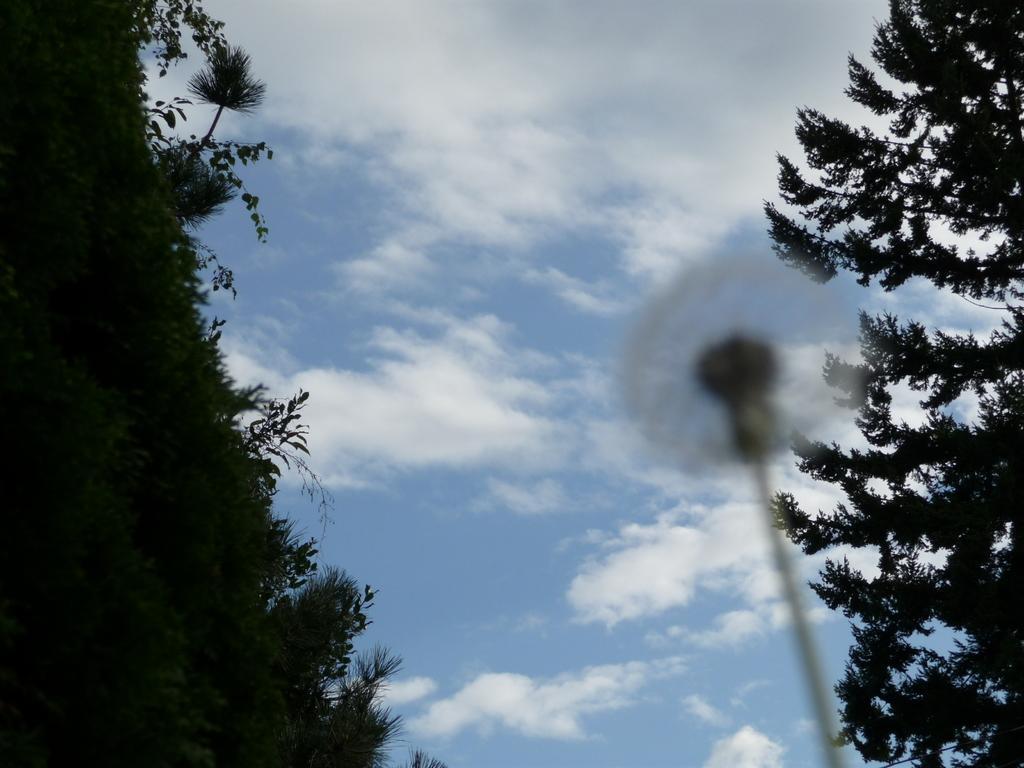Please provide a concise description of this image. In this image on the right side and left side there are some trees, and in the center there is sky and one pole. 